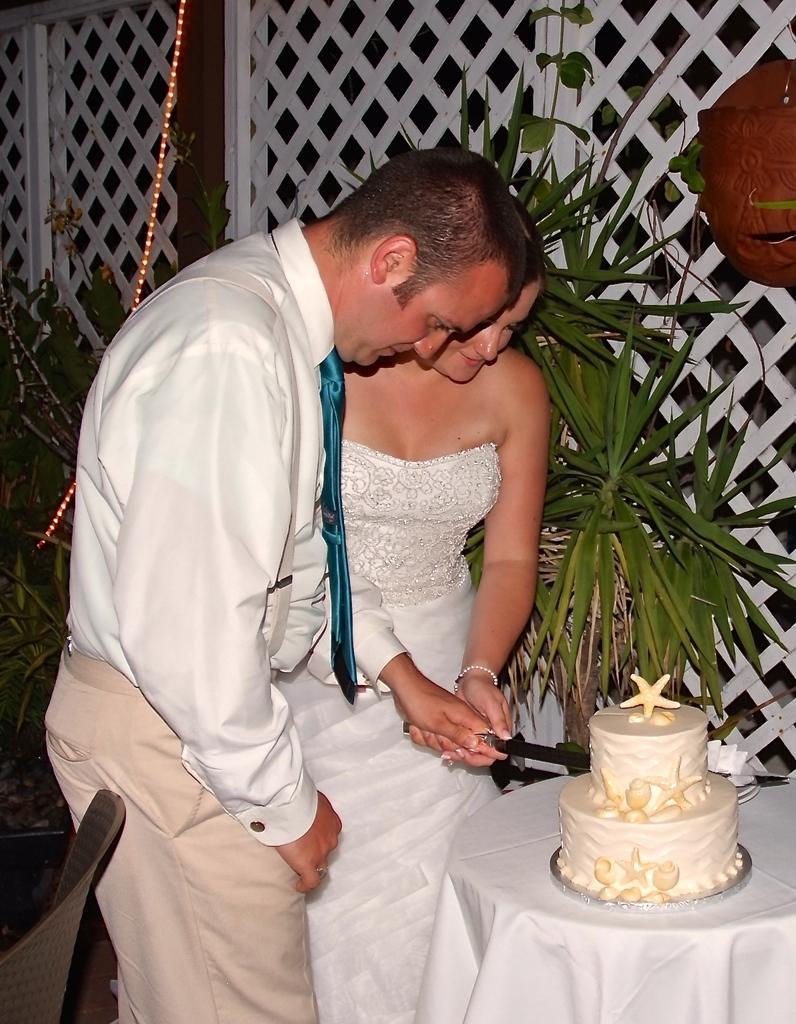Please provide a concise description of this image. In this image we can see a man and a woman cutting a cake with a knife. Here we can see a tablecloth, plants, chair, lights, grille, and an object. 